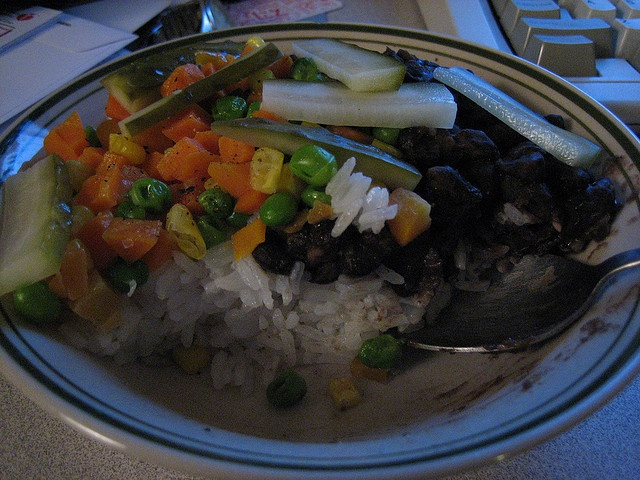Describe the objects in this image and their specific colors. I can see bowl in black, gray, maroon, and olive tones, keyboard in black and gray tones, spoon in black, navy, gray, and darkgreen tones, carrot in black, maroon, and brown tones, and carrot in black, maroon, and brown tones in this image. 